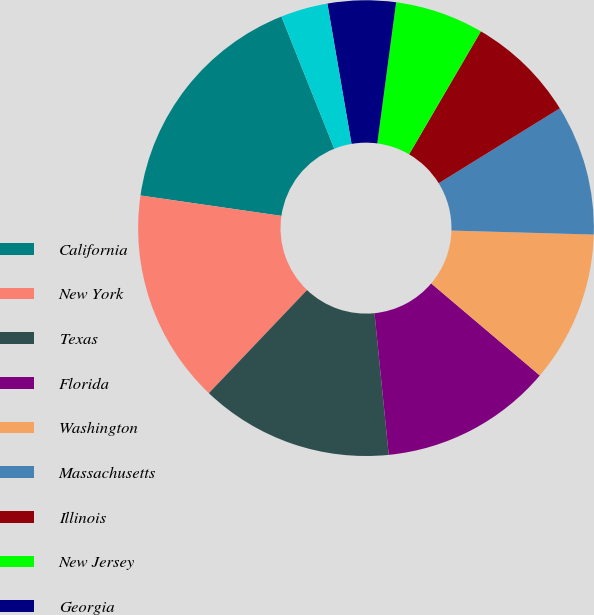Convert chart to OTSL. <chart><loc_0><loc_0><loc_500><loc_500><pie_chart><fcel>California<fcel>New York<fcel>Texas<fcel>Florida<fcel>Washington<fcel>Massachusetts<fcel>Illinois<fcel>New Jersey<fcel>Georgia<fcel>Ohio<nl><fcel>16.66%<fcel>15.18%<fcel>13.7%<fcel>12.22%<fcel>10.74%<fcel>9.26%<fcel>7.78%<fcel>6.3%<fcel>4.82%<fcel>3.34%<nl></chart> 